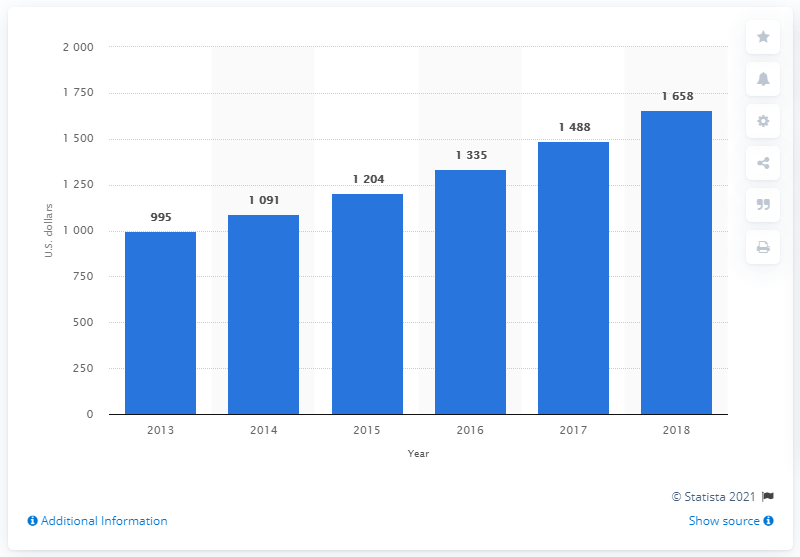Point out several critical features in this image. Pakistan's consumer spending per capita in 2013 was approximately $995. 